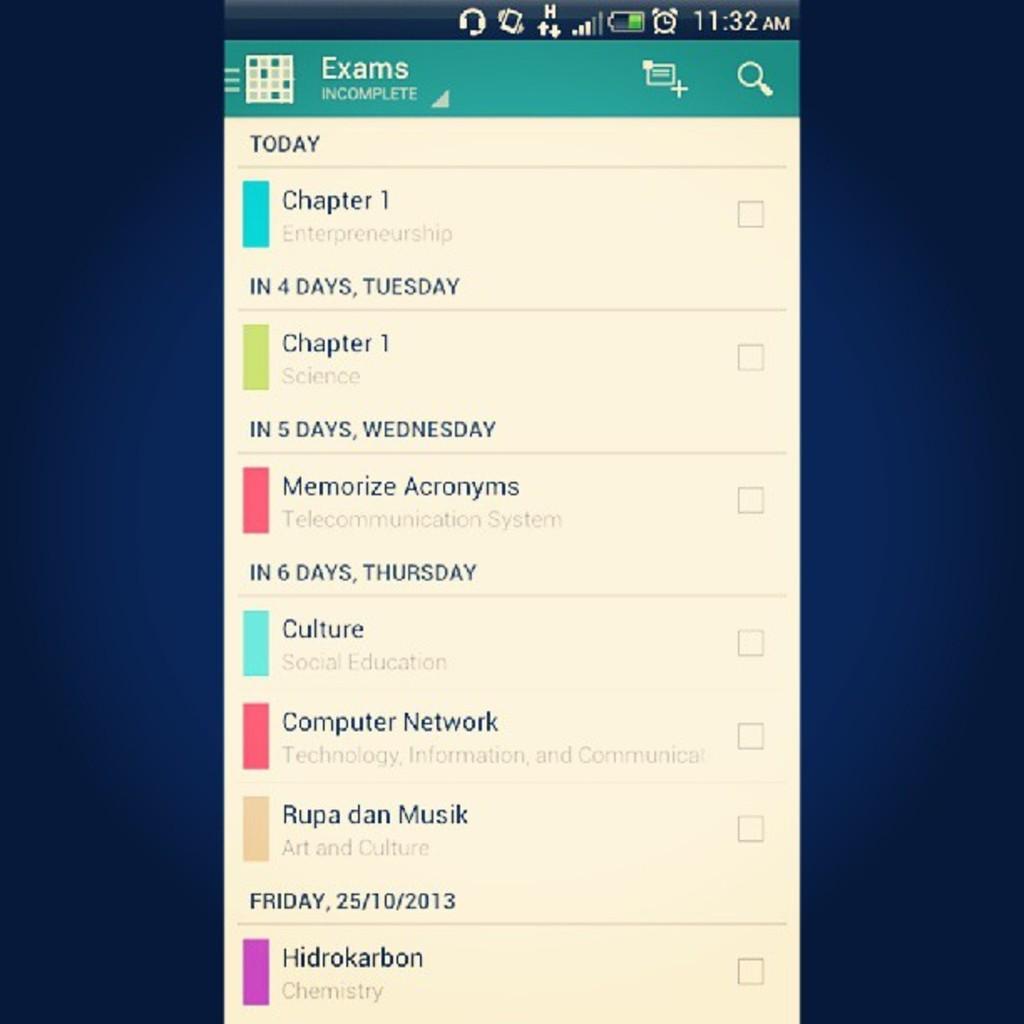What is incomplete?
Your answer should be very brief. Exams. What needs to be read today?
Your answer should be very brief. Chapter 1. 